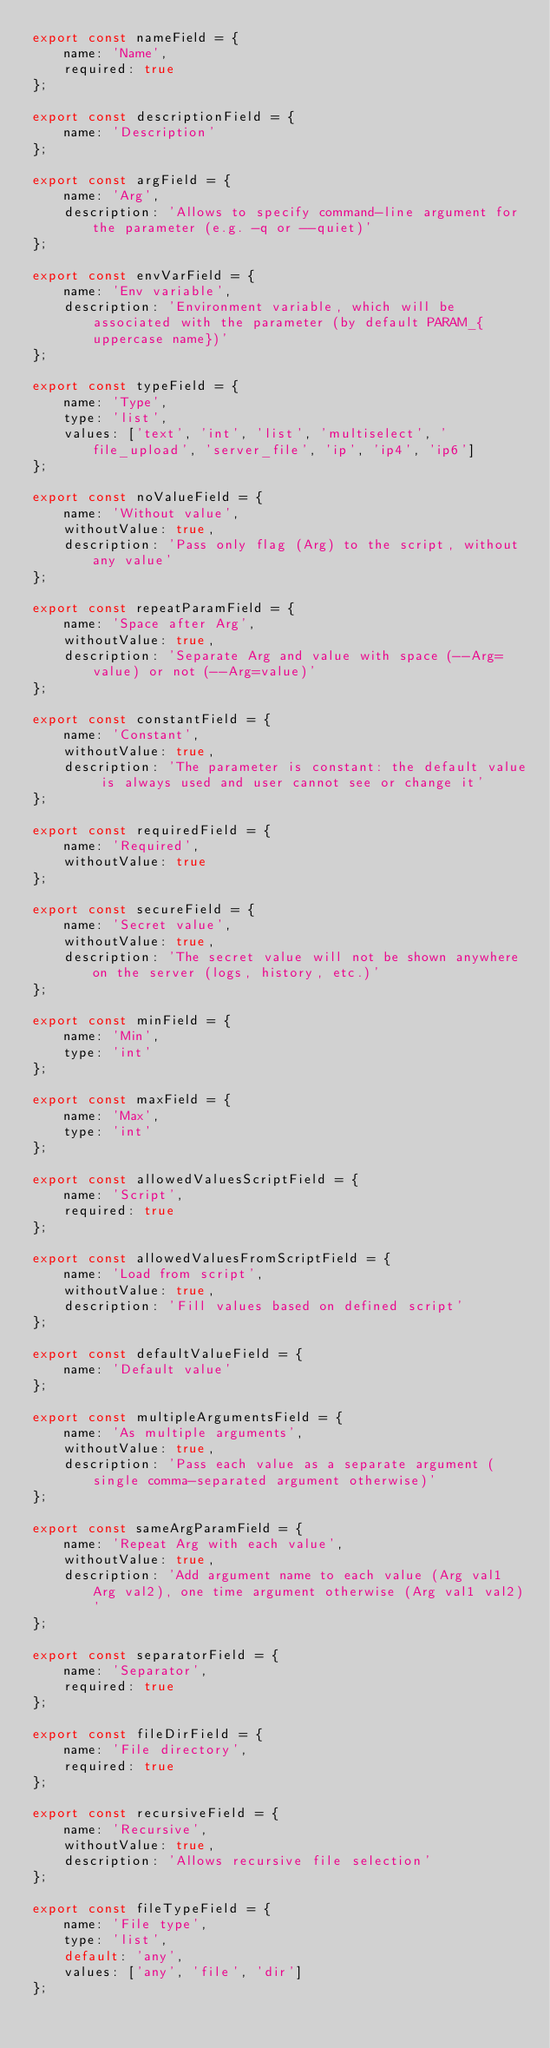<code> <loc_0><loc_0><loc_500><loc_500><_JavaScript_>export const nameField = {
    name: 'Name',
    required: true
};

export const descriptionField = {
    name: 'Description'
};

export const argField = {
    name: 'Arg',
    description: 'Allows to specify command-line argument for the parameter (e.g. -q or --quiet)'
};

export const envVarField = {
    name: 'Env variable',
    description: 'Environment variable, which will be associated with the parameter (by default PARAM_{uppercase name})'
};

export const typeField = {
    name: 'Type',
    type: 'list',
    values: ['text', 'int', 'list', 'multiselect', 'file_upload', 'server_file', 'ip', 'ip4', 'ip6']
};

export const noValueField = {
    name: 'Without value',
    withoutValue: true,
    description: 'Pass only flag (Arg) to the script, without any value'
};

export const repeatParamField = {
    name: 'Space after Arg',
    withoutValue: true,
    description: 'Separate Arg and value with space (--Arg= value) or not (--Arg=value)'
};

export const constantField = {
    name: 'Constant',
    withoutValue: true,
    description: 'The parameter is constant: the default value is always used and user cannot see or change it'
};

export const requiredField = {
    name: 'Required',
    withoutValue: true
};

export const secureField = {
    name: 'Secret value',
    withoutValue: true,
    description: 'The secret value will not be shown anywhere on the server (logs, history, etc.)'
};

export const minField = {
    name: 'Min',
    type: 'int'
};

export const maxField = {
    name: 'Max',
    type: 'int'
};

export const allowedValuesScriptField = {
    name: 'Script',
    required: true
};

export const allowedValuesFromScriptField = {
    name: 'Load from script',
    withoutValue: true,
    description: 'Fill values based on defined script'
};

export const defaultValueField = {
    name: 'Default value'
};

export const multipleArgumentsField = {
    name: 'As multiple arguments',
    withoutValue: true,
    description: 'Pass each value as a separate argument (single comma-separated argument otherwise)'
};

export const sameArgParamField = {
    name: 'Repeat Arg with each value',
    withoutValue: true,
    description: 'Add argument name to each value (Arg val1 Arg val2), one time argument otherwise (Arg val1 val2)'
};

export const separatorField = {
    name: 'Separator',
    required: true
};

export const fileDirField = {
    name: 'File directory',
    required: true
};

export const recursiveField = {
    name: 'Recursive',
    withoutValue: true,
    description: 'Allows recursive file selection'
};

export const fileTypeField = {
    name: 'File type',
    type: 'list',
    default: 'any',
    values: ['any', 'file', 'dir']
};</code> 